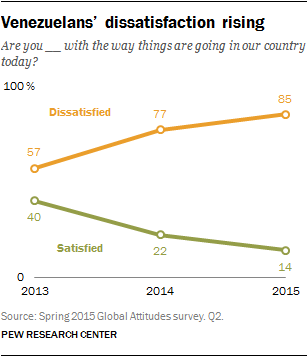Highlight a few significant elements in this photo. What is the highest value of the green line, between 40 and ? In 2013, 57% of the respondents expressed dissatisfaction with the state of affairs in the country. 